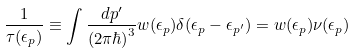Convert formula to latex. <formula><loc_0><loc_0><loc_500><loc_500>\frac { 1 } { \tau ( \epsilon _ { p } ) } \equiv \int \frac { d p ^ { \prime } } { ( 2 \pi \hbar { ) } ^ { 3 } } w ( \epsilon _ { p } ) \delta ( \epsilon _ { p } - \epsilon _ { p ^ { \prime } } ) = w ( \epsilon _ { p } ) \nu ( \epsilon _ { p } )</formula> 